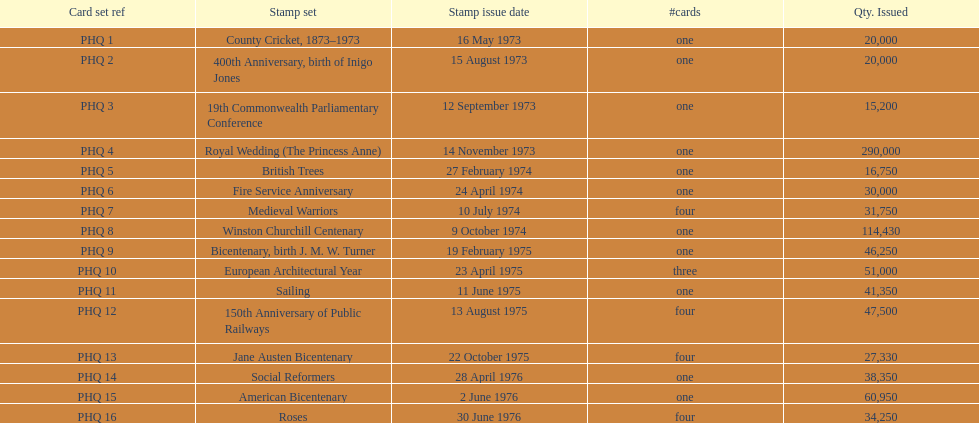Which was the only stamp set to have more than 200,000 issued? Royal Wedding (The Princess Anne). 